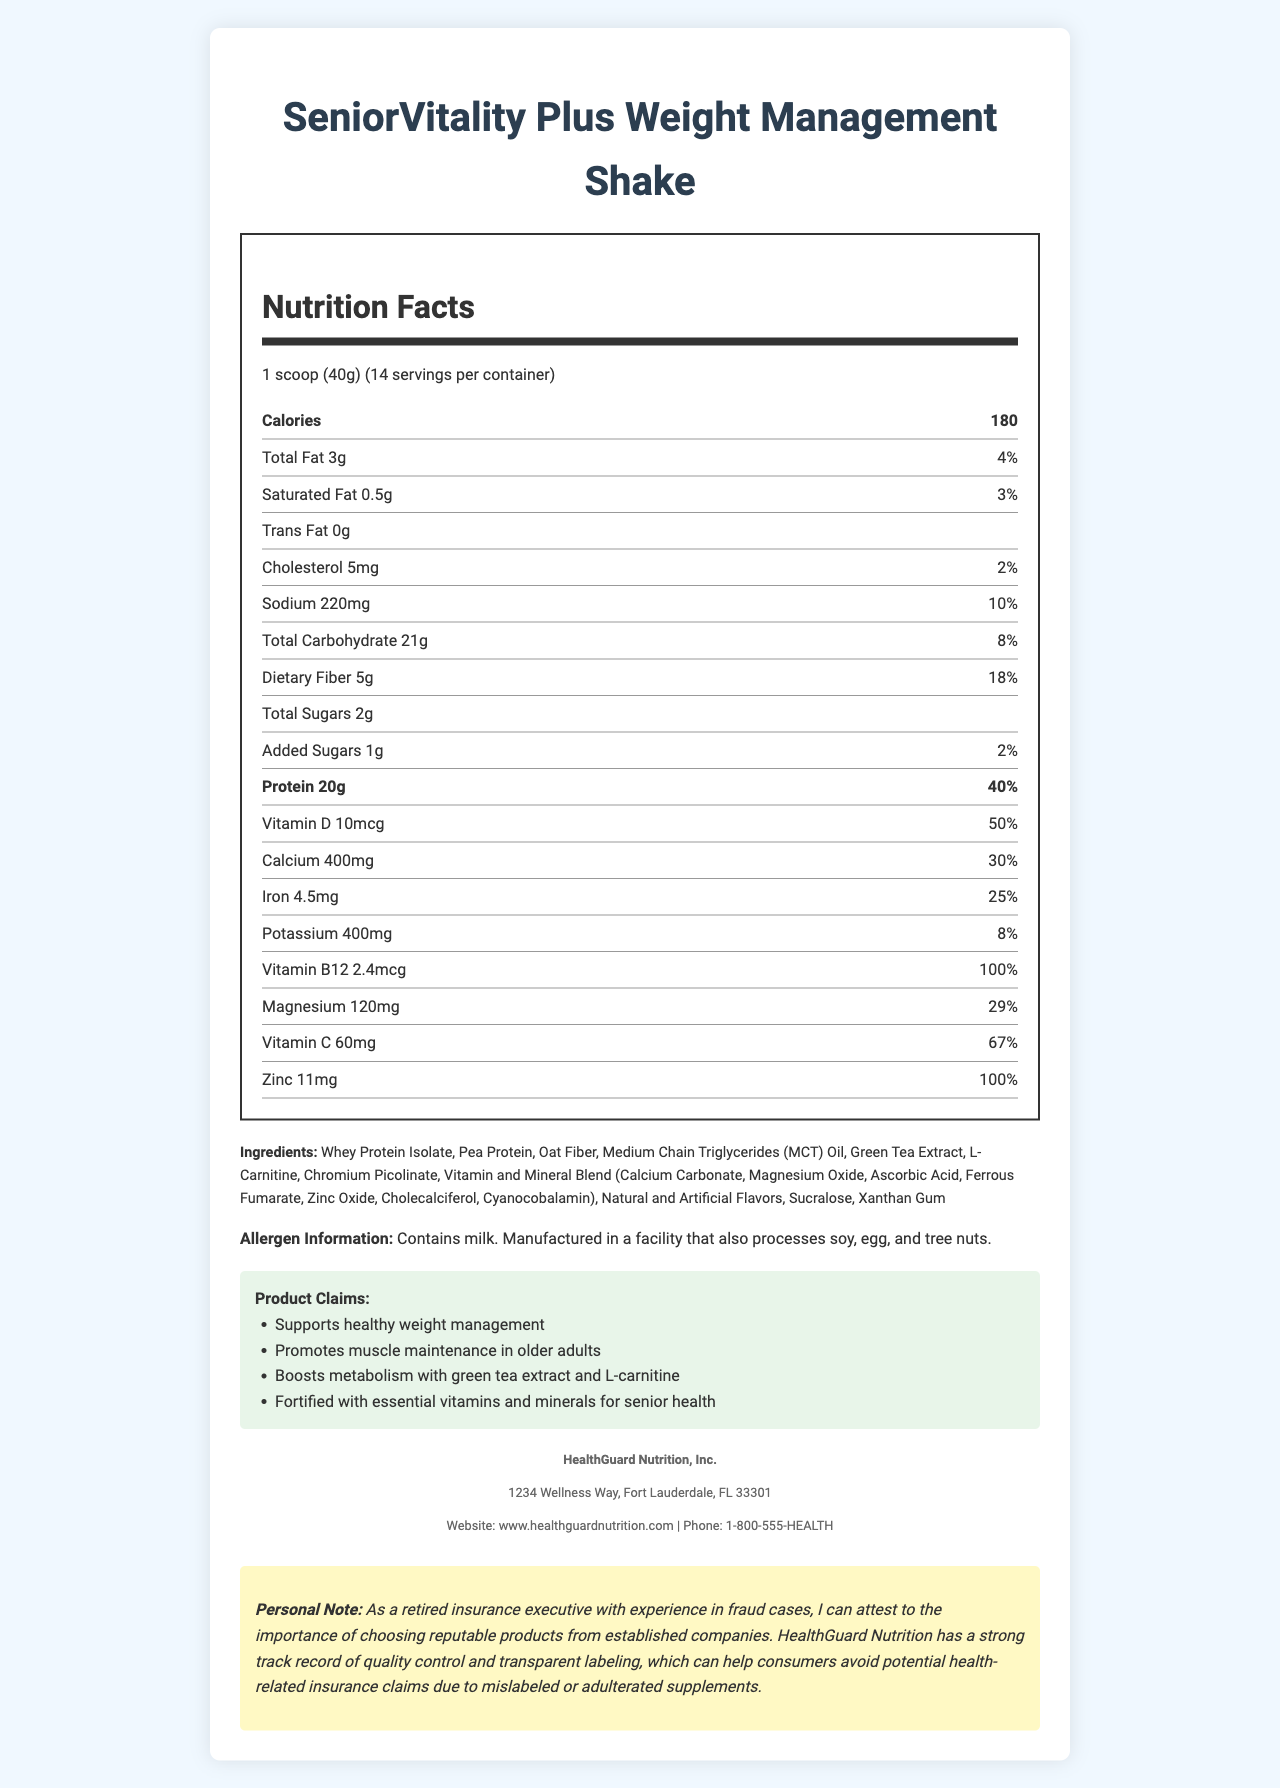what is the serving size of SeniorVitality Plus Weight Management Shake? The serving size is specified directly on the label as "1 scoop (40g)".
Answer: 1 scoop (40g) how many calories are in one serving? The label lists "Calories" as 180 per serving.
Answer: 180 what is the percentage daily value of dietary fiber in one serving? The label states that the daily value percentage for dietary fiber is 18%.
Answer: 18% how much protein does one serving contain? The amount of protein per serving is listed as 20g.
Answer: 20g which vitamins and minerals have a daily value percentage of 100% or more? The label shows Vitamin B12 and Zinc both at 100% daily value.
Answer: Vitamin B12 and Zinc what types of proteins are included in the ingredients? A. Whey Protein Isolate B. Pea Protein C. Soy Protein D. Egg Protein E. A and B The ingredients list includes Whey Protein Isolate and Pea Protein but does not mention Soy or Egg Protein.
Answer: E. A and B which ingredient is not included in SeniorVitality Plus? A. Green Tea Extract B. Sucralose C. L-carnitine D. Soy Protein The ingredient list includes Green Tea Extract, Sucralose, and L-carnitine, but not Soy Protein.
Answer: D. Soy Protein is the product fortified with essential vitamins and minerals? One of the claim statements mentions that the product is "Fortified with essential vitamins and minerals for senior health."
Answer: Yes does the product contain trans fat? The label specifies "Trans Fat 0g," indicating there is no trans fat in the product.
Answer: No summarize the main idea of this document. The document covers comprehensive nutritional details along with the product's intended health benefits and information about the manufacturer, stressing the significance of product reliability.
Answer: The document provides detailed nutritional information about the SeniorVitality Plus Weight Management Shake, highlighting its serving size, calories, macronutrients, vitamins, and minerals, along with a list of ingredients and allergen information. It also includes health claims made by the manufacturer, HealthGuard Nutrition, aimed at supporting weight management and senior health. Additionally, there is a personal note emphasizing the importance of choosing reputable products. who manufactures the SeniorVitality Plus Weight Management Shake? The manufacturer information section lists HealthGuard Nutrition, Inc. as the manufacturer.
Answer: HealthGuard Nutrition, Inc. what are the metabolism-boosting ingredients included in the shake? The claim statements mention that the shake boosts metabolism using Green Tea Extract and L-Carnitine.
Answer: Green Tea Extract and L-Carnitine how many servings are there per container? The label mentions "14 servings per container."
Answer: 14 list any allergens included in the product. The allergen information section specifies that the product contains milk and is made in a facility that processes soy, egg, and tree nuts.
Answer: Contains milk. Manufactured in a facility that also processes soy, egg, and tree nuts. does the document provide details on the product's flavor? The document lists "Natural and Artificial Flavors" but does not specify a particular flavor.
Answer: No what is the daily percentage value of magnesium in one serving? The label lists the daily percentage value of magnesium as 29%.
Answer: 29% what kind of oil is used in the product? The ingredient list includes Medium Chain Triglycerides (MCT) Oil.
Answer: Medium Chain Triglycerides (MCT) Oil 